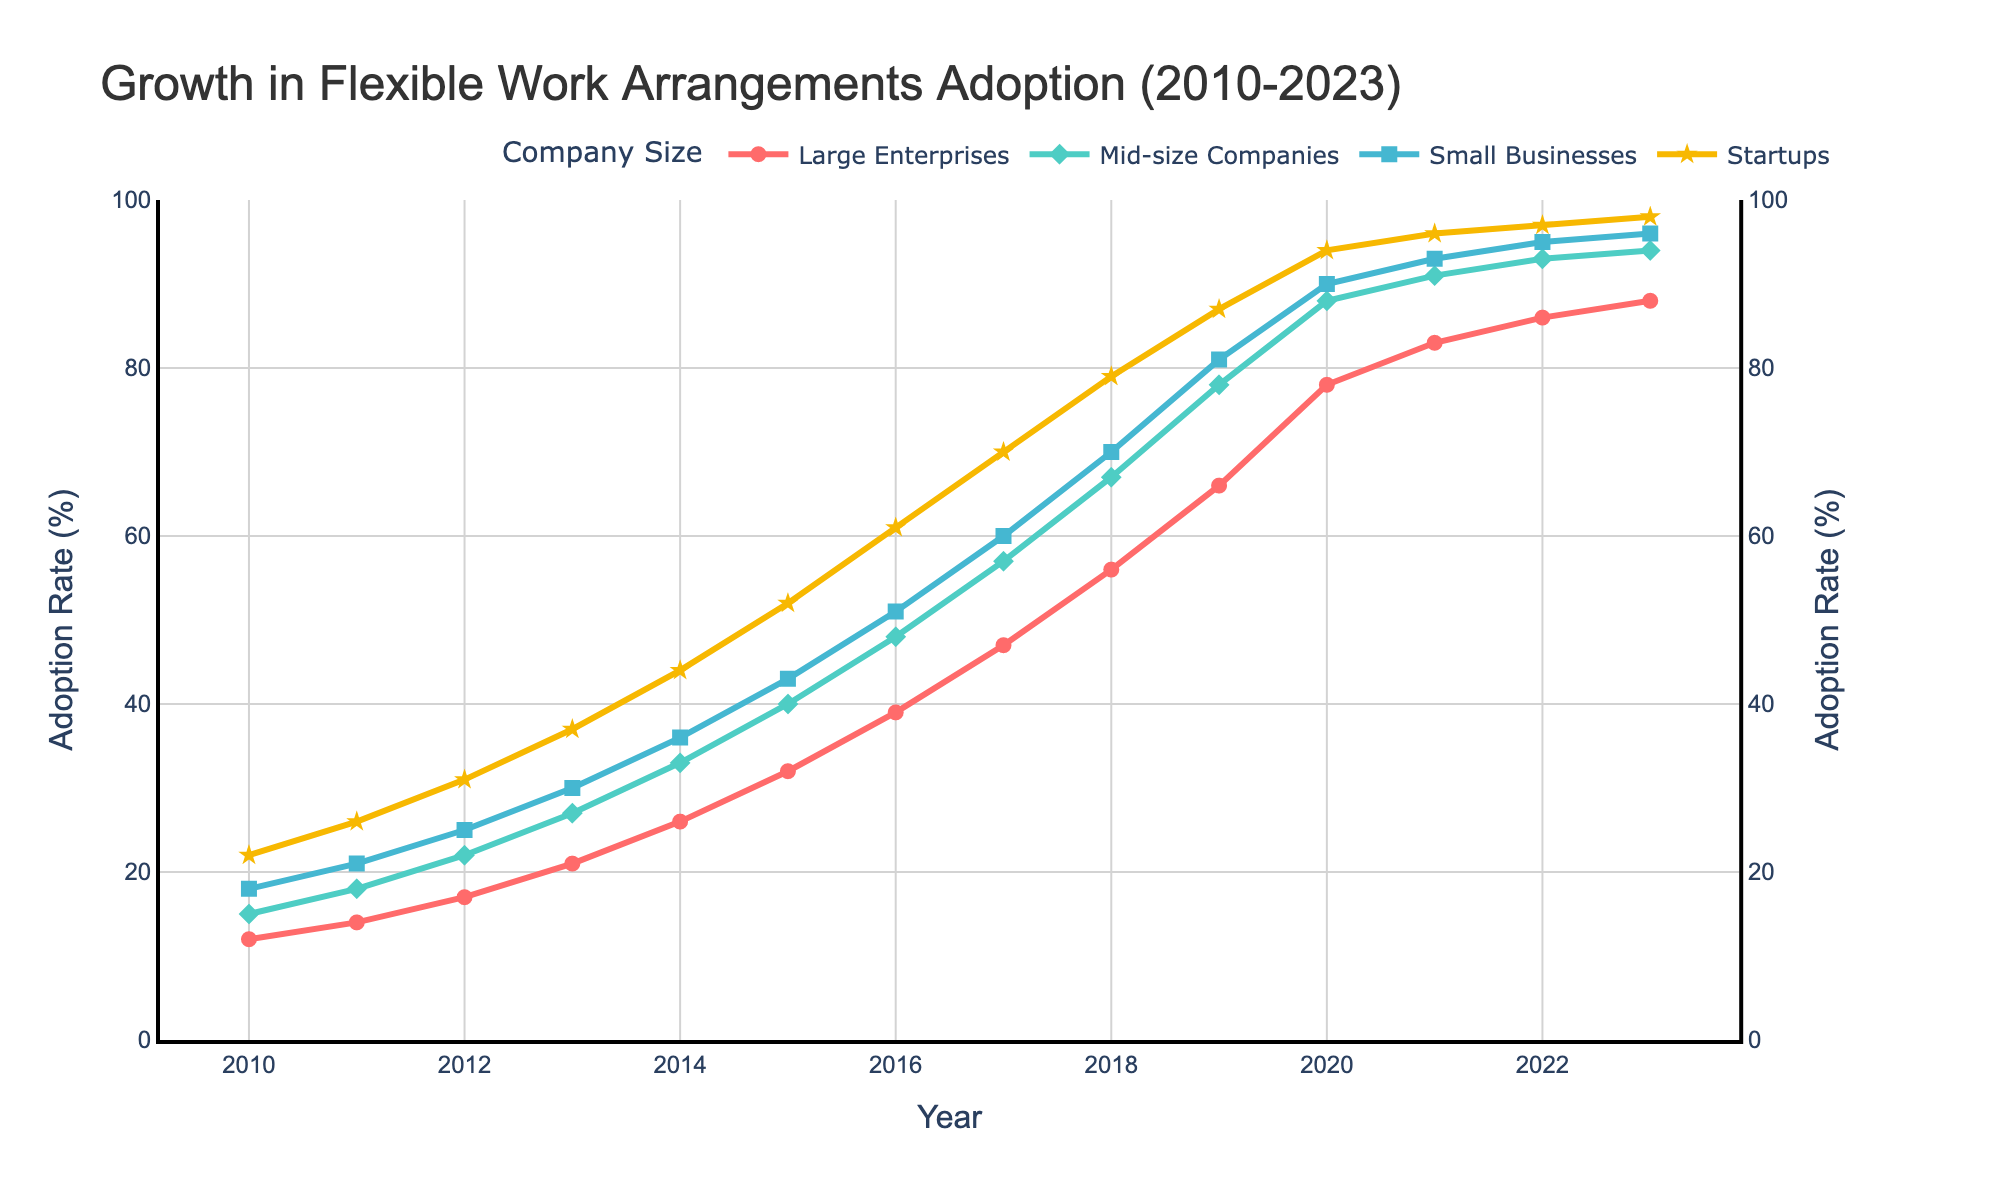what's the increase in the adoption rate for Large Enterprises between 2010 and 2023? The adoption rate for Large Enterprises in 2010 is 12%, and in 2023 it is 88%. The increase is calculated as 88% - 12% = 76%
Answer: 76% which company size had the highest adoption rate in 2023? By looking at the adoption rates in 2023 for each company size, Startups have the highest value at 98%
Answer: Startups what is the adoption rate difference between Mid-size Companies and Small Businesses in 2015? In 2015, the adoption rate for Mid-size Companies is 40%, and for Small Businesses, it is 43%. The difference is calculated as 43% - 40% = 3%
Answer: 3% compare the general trends for Large Enterprises and Startups from 2010 to 2023 Both Large Enterprises and Startups show a significant increase in adoption rates from 2010 to 2023. Startups increase from 22% to 98%, while Large Enterprises increase from 12% to 88%. The overall trend for both is upward.
Answer: upward trend for both what is the visual representation (color and marker symbol) used for Small Businesses in the plot? In the plot, Small Businesses are represented by a blue line with square-shaped markers
Answer: blue line with squares what year did all company sizes first achieve an adoption rate of at least 50%? Checking the data, we see that 2017 is the first year when the adoption rate for all company sizes (Large Enterprises: 47%, Mid-size Companies: 57%, Small Businesses: 60%, Startups: 70%) exceeds 50%
Answer: 2017 which company size showed the steepest increase in adoption between 2020 and 2021? By examining the data, Startups increased from 94% in 2020 to 96% in 2021, which is a 2% increase. The other companies' increases are less steep.
Answer: Startups what is the average adoption rate for Startups from 2010 to 2015? Summing the adoption rates for Startups between 2010 and 2015: 22 + 26 + 31 + 37 + 44 + 52 = 212. There are 6 years, so the average is 212 / 6 = 35.33%
Answer: 35.33% which company size had the most consistent growth from 2010 to 2023? All companies show growth, but Mid-size Companies have a more uniform and steady increase each year, with no abrupt jumps.
Answer: Mid-size Companies 